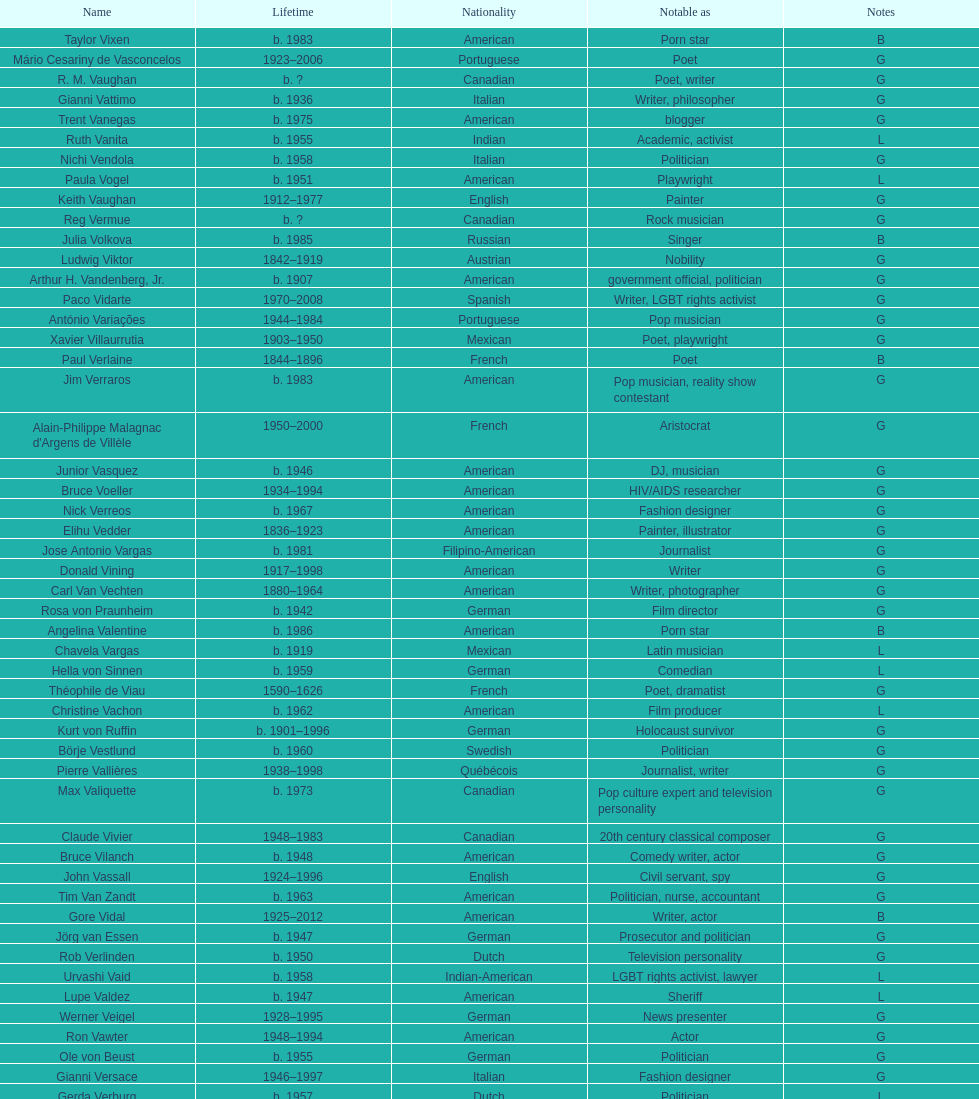Which is the previous name from lupe valdez Urvashi Vaid. 